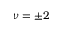<formula> <loc_0><loc_0><loc_500><loc_500>\nu = \pm 2</formula> 